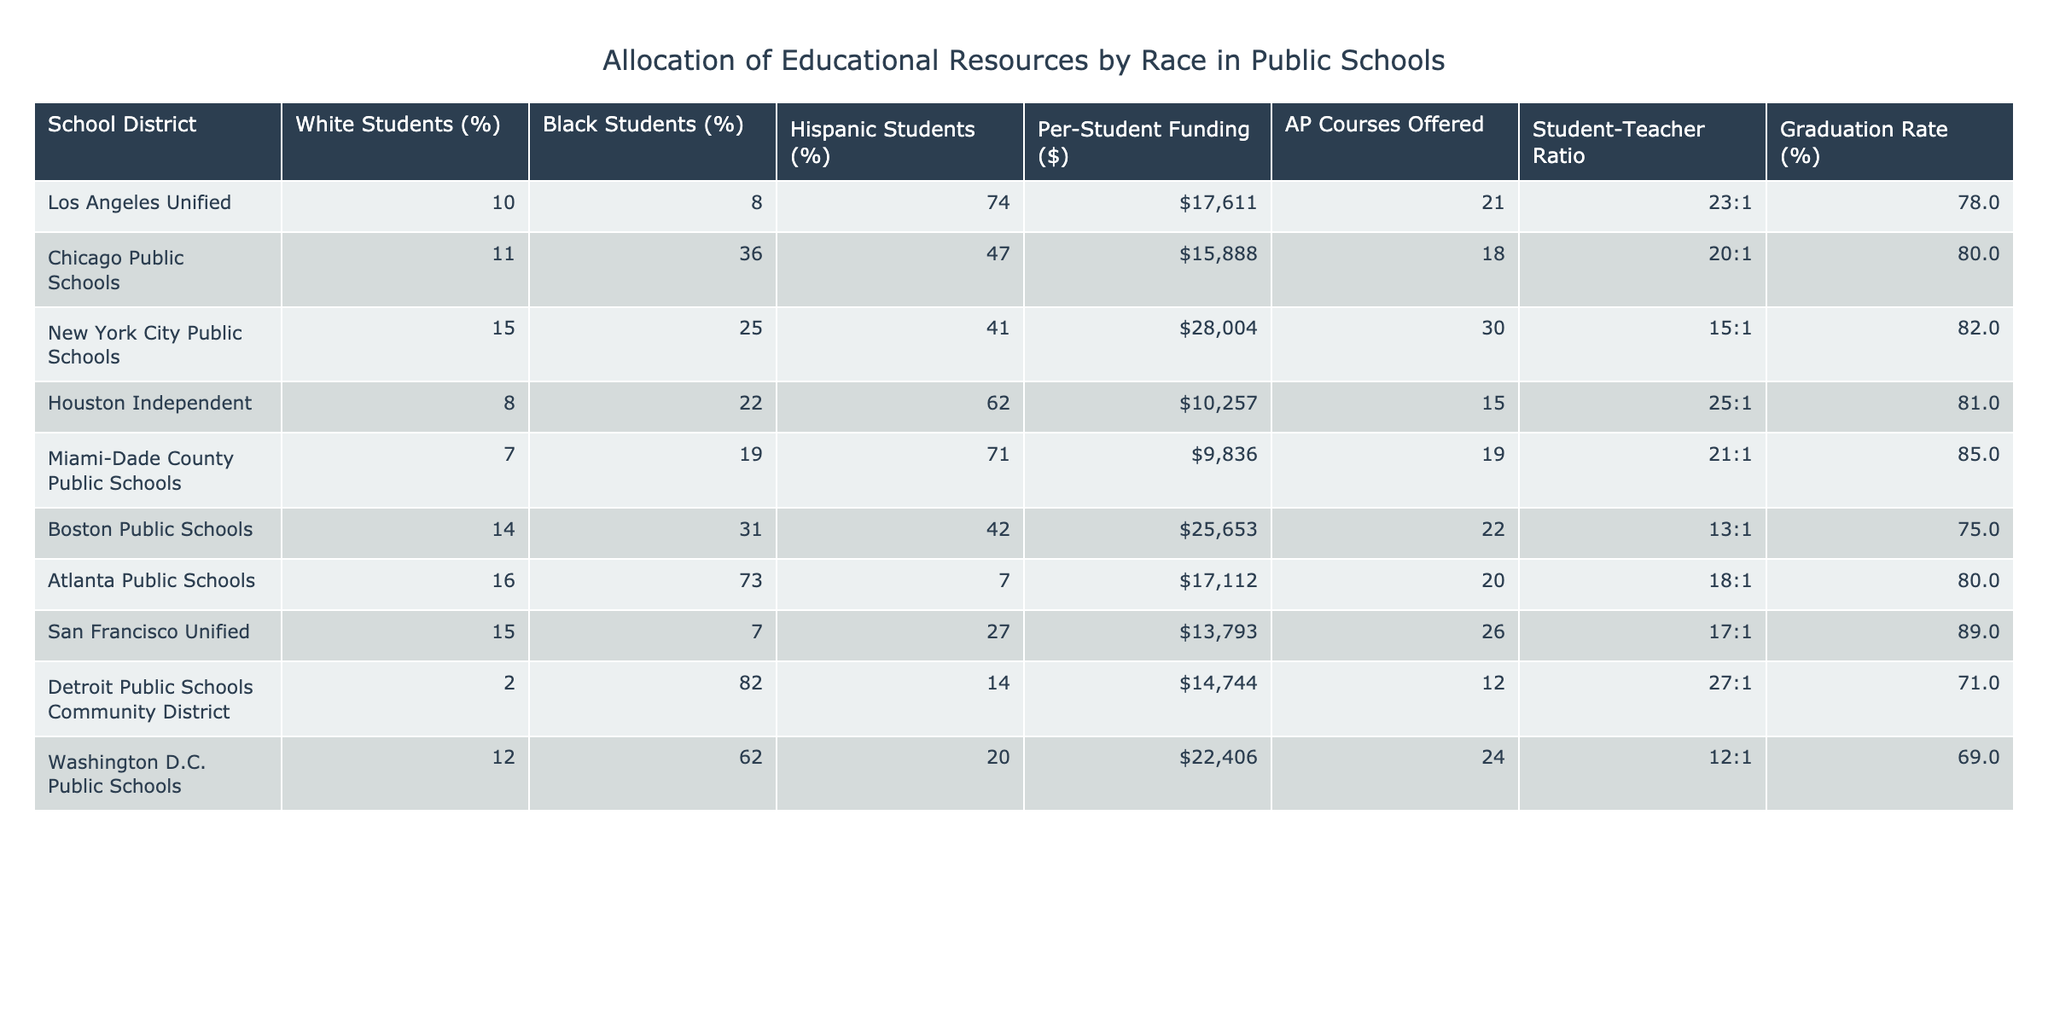What is the highest percentage of Black students in a school district? The highest percentage of Black students can be found by looking through the Black Students (%) column. The maximum value in this column is 82%, which corresponds to the Detroit Public Schools Community District.
Answer: 82% Which school district has the lowest per-student funding? By examining the Per-Student Funding ($) column, the lowest funding figure appears to be $9,836 for Miami-Dade County Public Schools.
Answer: $9,836 What is the average percentage of White students across all districts? To calculate the average percentage of White students, sum the percentages from the column (10 + 11 + 15 + 8 + 7 + 14 + 16 + 15 + 2 + 12) which equals  96, then divide by the number of districts (10). The average percentage is 96 / 10 = 9.6%.
Answer: 9.6% Is the graduation rate higher in New York City Public Schools than in Atlanta Public Schools? Comparing the Graduation Rate (%) column, New York City Public Schools has 82%, while Atlanta Public Schools has 80%. Since 82% is greater than 80%, the statement is true.
Answer: Yes Which school district has the highest student-teacher ratio? The Student-Teacher Ratio column reveals that Detroit Public Schools Community District has the highest ratio of 27:1.
Answer: 27:1 If we only consider the districts with a majority of Hispanic students, what is the total funding allocated (sum of per-student funding)? The districts with a majority Hispanic population are Los Angeles Unified, Houston Independent, Miami-Dade County Public Schools, and Chicago Public Schools. Their per-student funding is $17,611, $10,257, $9,836, and $15,888, respectively. The total funding is calculated as (17,611 + 10,257 + 9,836 + 15,888) = 53,592.
Answer: $53,592 Are there more AP courses offered in any district than in Houston Independent? The AP Courses Offered column indicates Houston Independent offers 15 courses. After checking other districts, Boston Public Schools offers 22 AP courses, which is more than Houston Independent.
Answer: Yes What is the difference in percentage of Hispanic students between Miami-Dade County Public Schools and Atlanta Public Schools? In the Hispanic Students (%) column, Miami-Dade County Public Schools has 71% and Atlanta Public Schools has 7%. The difference is 71% - 7% = 64%.
Answer: 64% In which school district is the proportion of White students closest to the national average of 50%? By reviewing the White Students (%) column, the closest to 50% is Boston Public Schools with 14%, which is the highest among the districts but still significantly lower than 50%.
Answer: Boston Public Schools What is the trend in graduation rates compared to per-student funding across these school districts? By examining the Graduation Rate (%) and Per-Student Funding ($) columns, there does not seem to be a direct trend; for instance, higher funding (like NYC) doesn't always correlate with higher graduation rates. A detailed inspection shows varied results.
Answer: No clear trend 